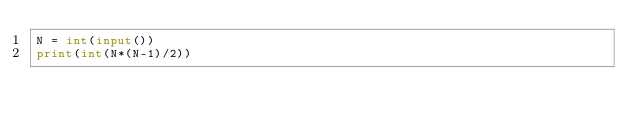Convert code to text. <code><loc_0><loc_0><loc_500><loc_500><_Python_>N = int(input())
print(int(N*(N-1)/2))</code> 